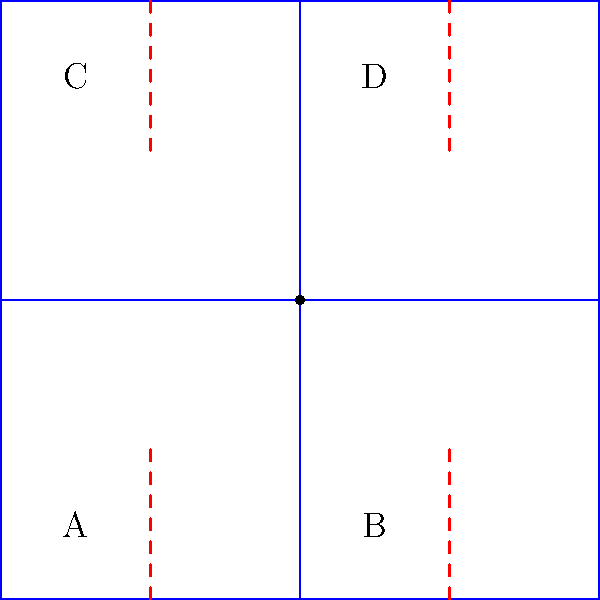You're crafting a paper model of a kulintang, a traditional Filipino percussion instrument. Given the folding pattern above, where blue lines represent folds and red dashed lines represent cuts, which sequence of folds will create a bowl-like shape similar to a kulintang gong? To create a bowl-like shape similar to a kulintang gong, we need to follow these steps:

1. Identify the center point: The dot in the middle (1,1) represents the center of the kulintang gong.

2. Analyze the fold lines:
   - Vertical fold line: divides the square into two equal halves
   - Horizontal fold line: divides the square into two equal halves
   - Four corner cuts: allow the corners to be lifted to form the bowl shape

3. Folding sequence:
   a) First, fold along the vertical line (1,0)--(1,2), bringing the left and right halves together.
   b) Unfold, then fold along the horizontal line (0,1)--(2,1), bringing the top and bottom halves together.
   c) Unfold again, preparing for the final shaping.

4. Shaping the bowl:
   d) Lift corners A, B, C, and D towards the center point.
   e) As you lift the corners, the paper will naturally curve inward along the fold lines.

5. Final adjustments:
   f) Gently press the center to create a slight depression, mimicking the kulintang gong's shape.

This folding sequence will transform the flat pattern into a bowl-like shape resembling a kulintang gong.
Answer: Vertical fold, horizontal fold, lift corners to center 